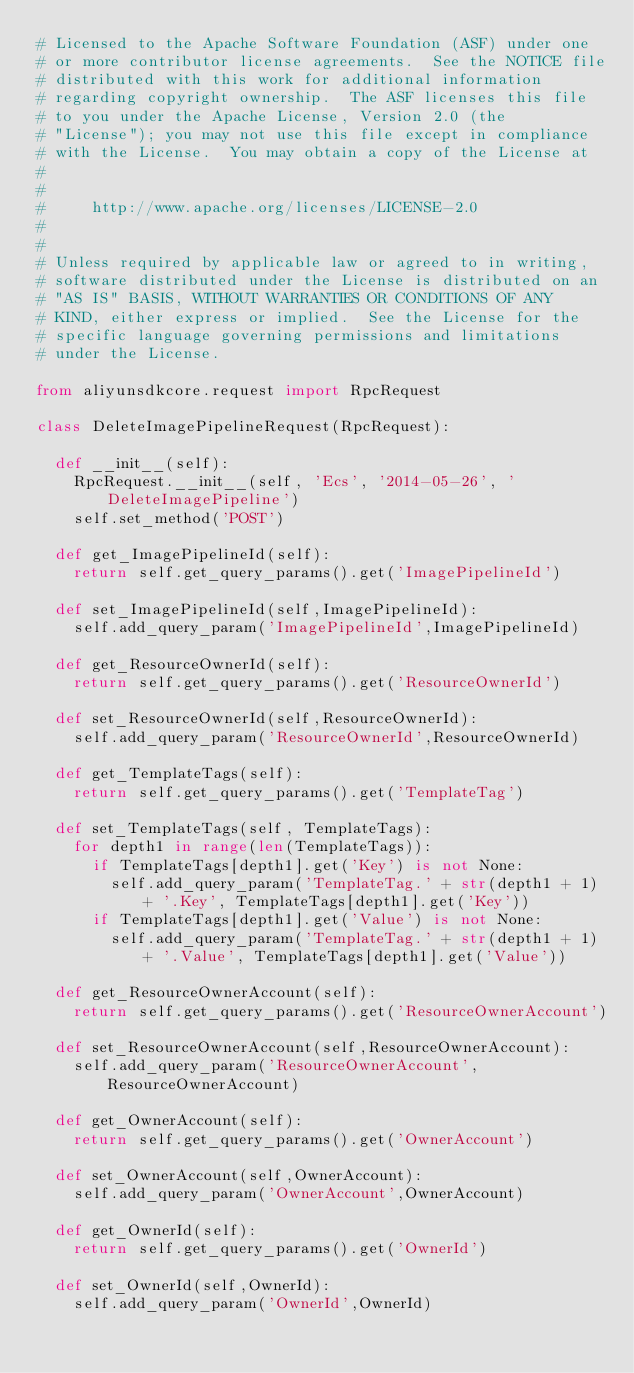<code> <loc_0><loc_0><loc_500><loc_500><_Python_># Licensed to the Apache Software Foundation (ASF) under one
# or more contributor license agreements.  See the NOTICE file
# distributed with this work for additional information
# regarding copyright ownership.  The ASF licenses this file
# to you under the Apache License, Version 2.0 (the
# "License"); you may not use this file except in compliance
# with the License.  You may obtain a copy of the License at
#
#
#     http://www.apache.org/licenses/LICENSE-2.0
#
#
# Unless required by applicable law or agreed to in writing,
# software distributed under the License is distributed on an
# "AS IS" BASIS, WITHOUT WARRANTIES OR CONDITIONS OF ANY
# KIND, either express or implied.  See the License for the
# specific language governing permissions and limitations
# under the License.

from aliyunsdkcore.request import RpcRequest

class DeleteImagePipelineRequest(RpcRequest):

	def __init__(self):
		RpcRequest.__init__(self, 'Ecs', '2014-05-26', 'DeleteImagePipeline')
		self.set_method('POST')

	def get_ImagePipelineId(self):
		return self.get_query_params().get('ImagePipelineId')

	def set_ImagePipelineId(self,ImagePipelineId):
		self.add_query_param('ImagePipelineId',ImagePipelineId)

	def get_ResourceOwnerId(self):
		return self.get_query_params().get('ResourceOwnerId')

	def set_ResourceOwnerId(self,ResourceOwnerId):
		self.add_query_param('ResourceOwnerId',ResourceOwnerId)

	def get_TemplateTags(self):
		return self.get_query_params().get('TemplateTag')

	def set_TemplateTags(self, TemplateTags):
		for depth1 in range(len(TemplateTags)):
			if TemplateTags[depth1].get('Key') is not None:
				self.add_query_param('TemplateTag.' + str(depth1 + 1) + '.Key', TemplateTags[depth1].get('Key'))
			if TemplateTags[depth1].get('Value') is not None:
				self.add_query_param('TemplateTag.' + str(depth1 + 1) + '.Value', TemplateTags[depth1].get('Value'))

	def get_ResourceOwnerAccount(self):
		return self.get_query_params().get('ResourceOwnerAccount')

	def set_ResourceOwnerAccount(self,ResourceOwnerAccount):
		self.add_query_param('ResourceOwnerAccount',ResourceOwnerAccount)

	def get_OwnerAccount(self):
		return self.get_query_params().get('OwnerAccount')

	def set_OwnerAccount(self,OwnerAccount):
		self.add_query_param('OwnerAccount',OwnerAccount)

	def get_OwnerId(self):
		return self.get_query_params().get('OwnerId')

	def set_OwnerId(self,OwnerId):
		self.add_query_param('OwnerId',OwnerId)</code> 